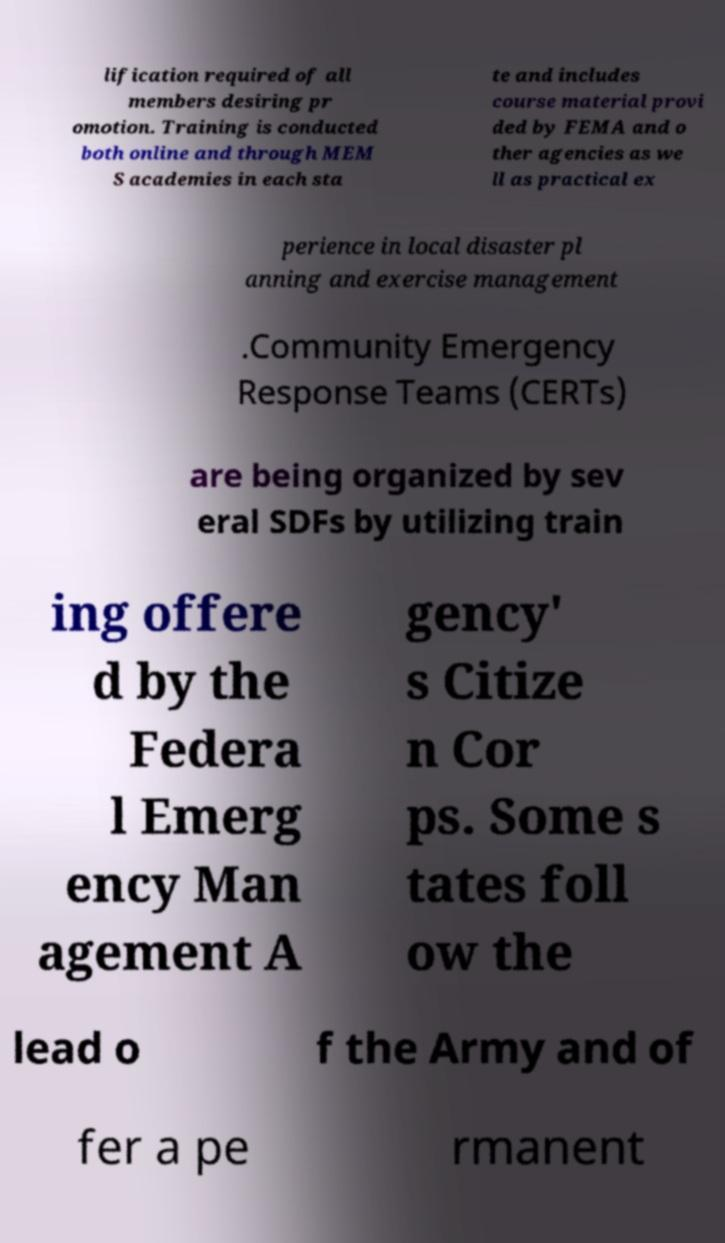For documentation purposes, I need the text within this image transcribed. Could you provide that? lification required of all members desiring pr omotion. Training is conducted both online and through MEM S academies in each sta te and includes course material provi ded by FEMA and o ther agencies as we ll as practical ex perience in local disaster pl anning and exercise management .Community Emergency Response Teams (CERTs) are being organized by sev eral SDFs by utilizing train ing offere d by the Federa l Emerg ency Man agement A gency' s Citize n Cor ps. Some s tates foll ow the lead o f the Army and of fer a pe rmanent 